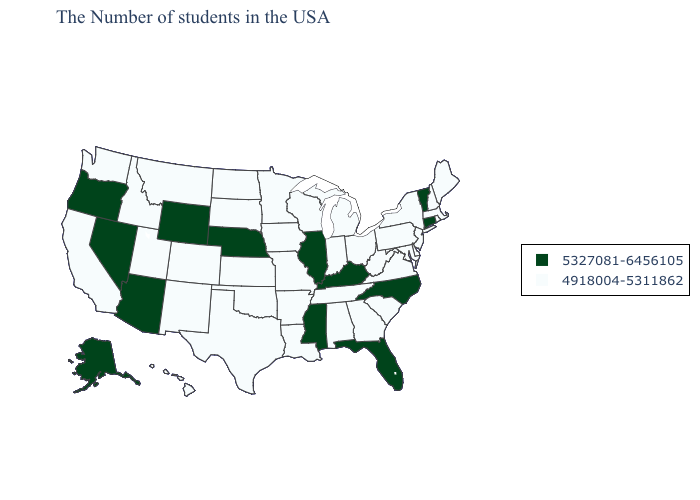Is the legend a continuous bar?
Short answer required. No. What is the lowest value in states that border Missouri?
Be succinct. 4918004-5311862. Name the states that have a value in the range 4918004-5311862?
Give a very brief answer. Maine, Massachusetts, Rhode Island, New Hampshire, New York, New Jersey, Delaware, Maryland, Pennsylvania, Virginia, South Carolina, West Virginia, Ohio, Georgia, Michigan, Indiana, Alabama, Tennessee, Wisconsin, Louisiana, Missouri, Arkansas, Minnesota, Iowa, Kansas, Oklahoma, Texas, South Dakota, North Dakota, Colorado, New Mexico, Utah, Montana, Idaho, California, Washington, Hawaii. What is the lowest value in states that border Mississippi?
Quick response, please. 4918004-5311862. What is the lowest value in states that border Tennessee?
Short answer required. 4918004-5311862. What is the value of California?
Be succinct. 4918004-5311862. Does Maine have the lowest value in the USA?
Answer briefly. Yes. What is the highest value in the South ?
Keep it brief. 5327081-6456105. Name the states that have a value in the range 5327081-6456105?
Give a very brief answer. Vermont, Connecticut, North Carolina, Florida, Kentucky, Illinois, Mississippi, Nebraska, Wyoming, Arizona, Nevada, Oregon, Alaska. What is the value of Texas?
Be succinct. 4918004-5311862. Does the map have missing data?
Short answer required. No. What is the highest value in the USA?
Keep it brief. 5327081-6456105. What is the value of Utah?
Answer briefly. 4918004-5311862. What is the value of Ohio?
Concise answer only. 4918004-5311862. Does Maine have a lower value than Oregon?
Answer briefly. Yes. 